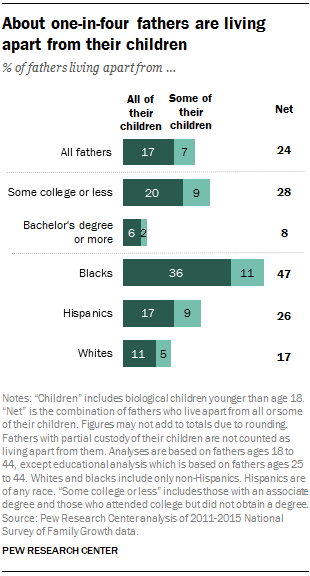Outline some significant characteristics in this image. The sum of all the bars above 20 or equal to 20 is 56. According to data, approximately 36% of Black fathers live apart from all of their children. 